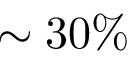<formula> <loc_0><loc_0><loc_500><loc_500>\sim 3 0 \%</formula> 